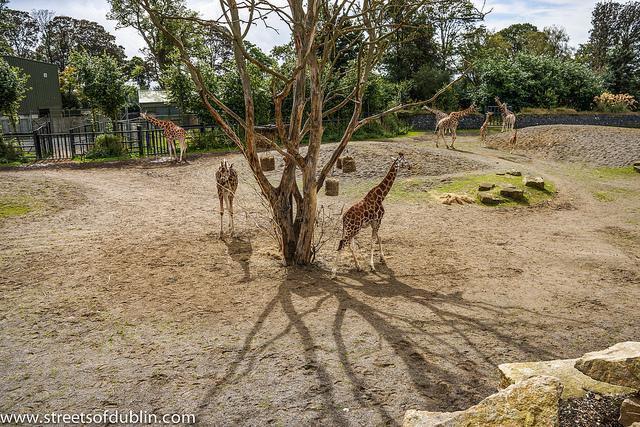What are the giraffes near?
Choose the right answer and clarify with the format: 'Answer: answer
Rationale: rationale.'
Options: Boats, pumpkins, trees, cows. Answer: trees.
Rationale: The giraffes are playing next to some trees. 